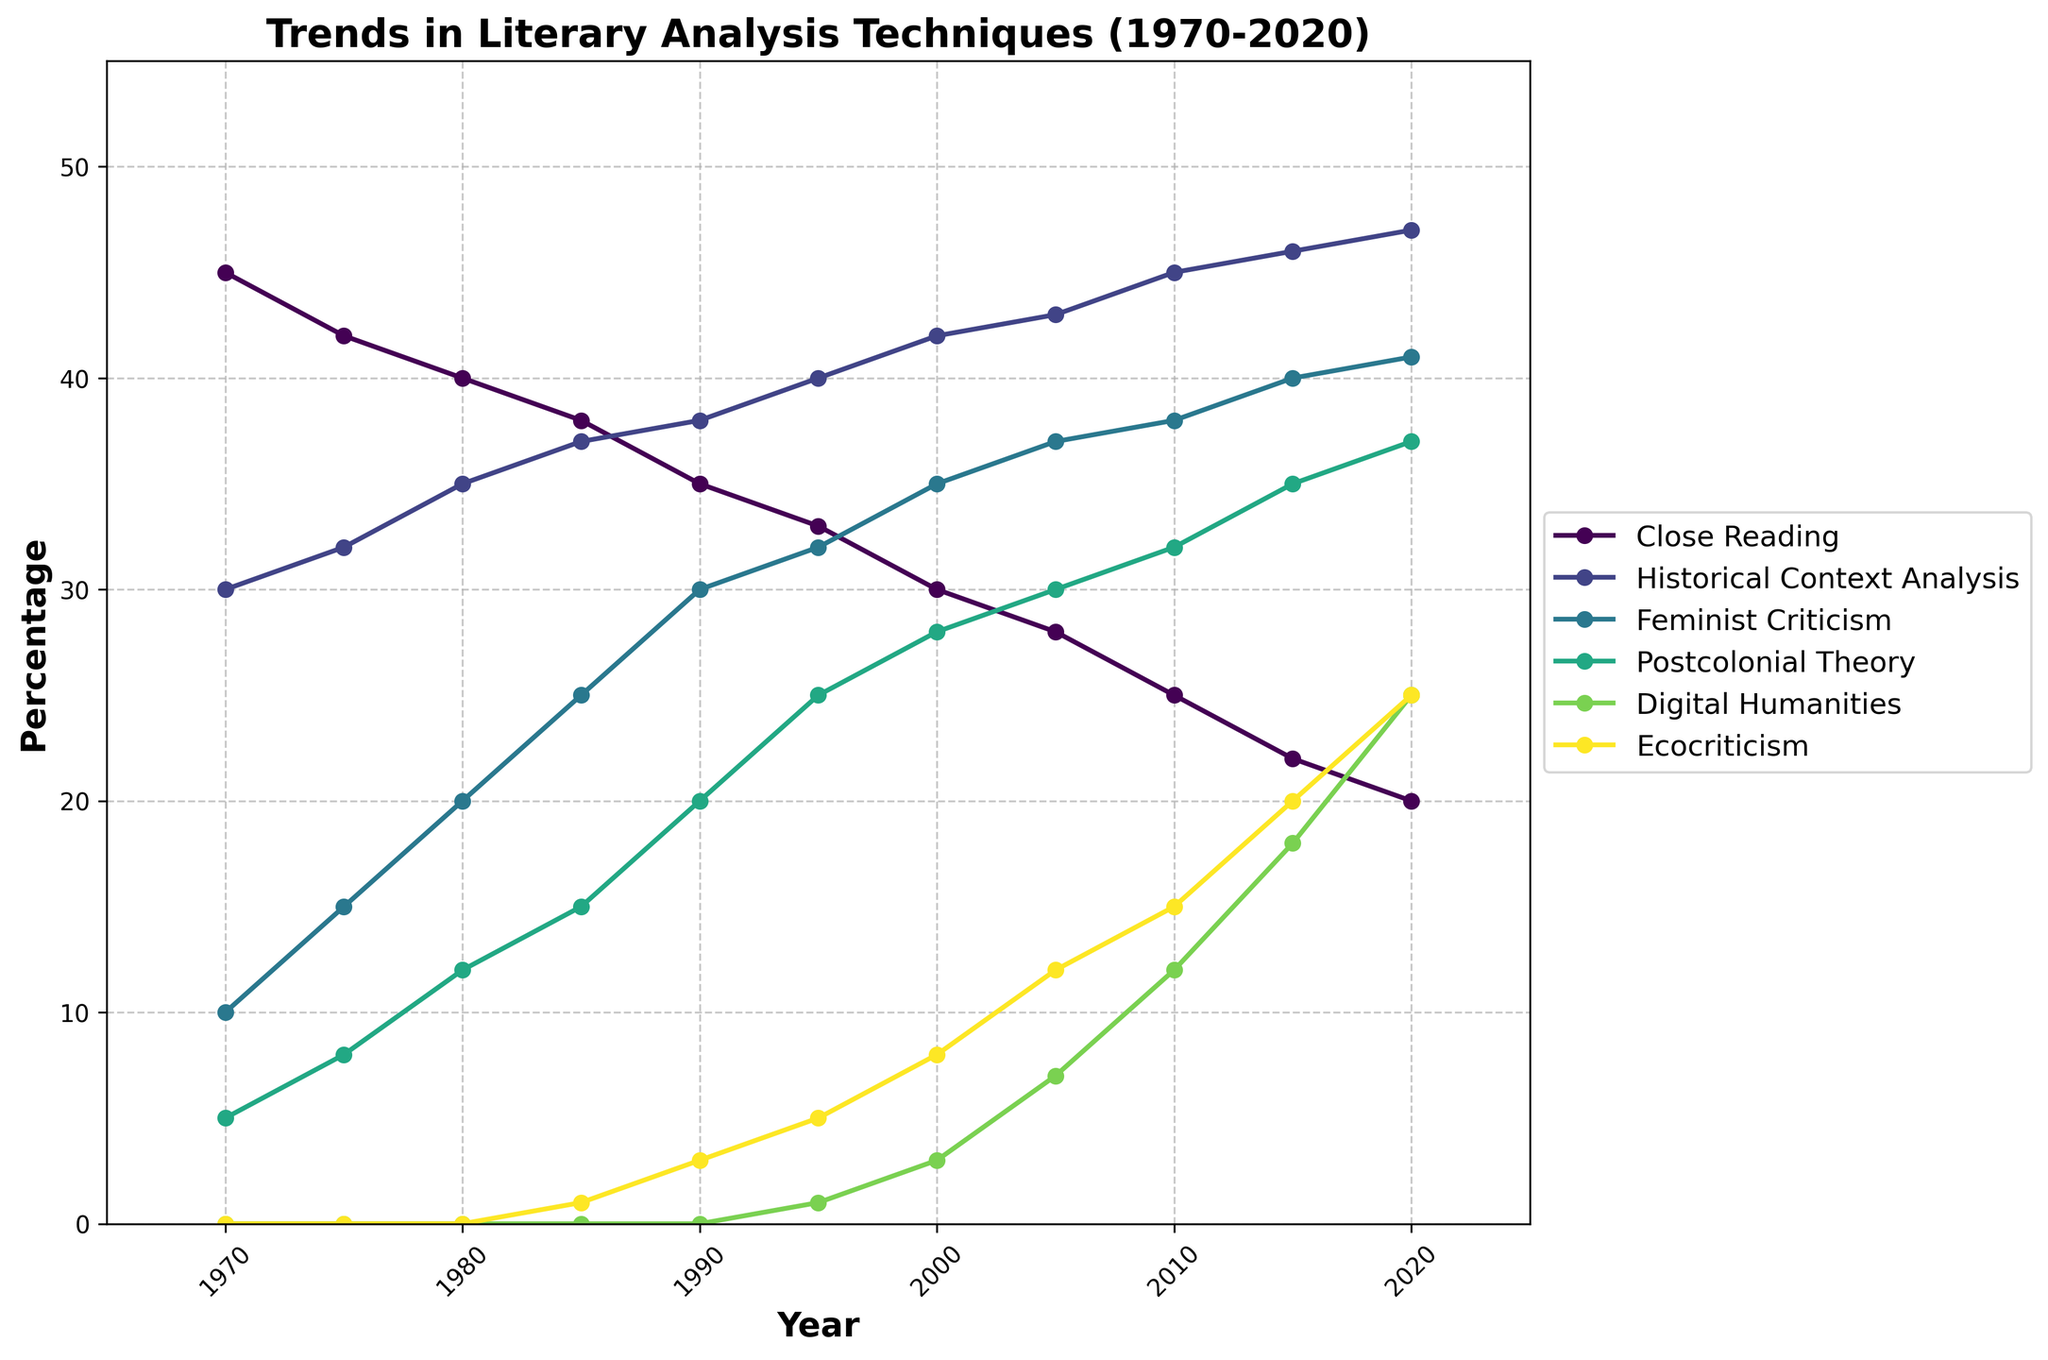Which technique showed the highest percentage in the year 2020? Observing the endpoint of the lines on the chart for the year 2020, the 'Historical Context Analysis' line reaches the highest point.
Answer: Historical Context Analysis How did the percentage of Close Reading change from 1970 to 2020? Refer to the 'Close Reading' line: it starts at 45% in 1970 and ends at 20% in 2020. The change is 45% - 20% = 25% decrease.
Answer: Decreased by 25% Which two techniques had the closest percentage values in 2000? Look at the data points for the year 2000. 'Postcolonial Theory' is at 28% and 'Feminist Criticism' is at 35%. Other pairs have larger differences.
Answer: Postcolonial Theory and Feminist Criticism In 1995, which technique had a smaller percentage than Feminist Criticism but larger than Ecocriticism? Check 1995 values: 'Feminist Criticism' is at 32%, 'Ecocriticism' is 5%. 'Postcolonial Theory' is 25%, which fits the criterion.
Answer: Postcolonial Theory Between which years did Digital Humanities show the most significant increase? Track the slope of the 'Digital Humanities' line; the steepest positive slope can be observed between 2015 and 2020.
Answer: 2015-2020 Did any technique decrease over the entire period from 1970 to 2020? Follow each line from start to end: 'Close Reading' starts at 45% and declines to 20%.
Answer: Close Reading Which technique exhibited the fastest growth in the 1990s? Examine slopes from 1990 to 2000: 'Postcolonial Theory' shows the most significant upward slope.
Answer: Postcolonial Theory What is the total combined percentage of Close Reading and Historical Context Analysis in 1980? Add percentages from 1980: Close Reading (40%) + Historical Context Analysis (35%) = 75%.
Answer: 75% How does the upward trend of Ecocriticism visually compare to that of Digital Humanities? Both lines show an increasing trend; however, the line for Digital Humanities increases at a steeper rate compared to Ecocriticism.
Answer: Digital Humanities increases faster Comparing 1970 and 2020, which technique shows the biggest percentage increase? Compare values: start in 1970 and end in 2020. 'Digital Humanities' rises from 0% to 25%, a 25% increase, which is the highest increase.
Answer: Digital Humanities 